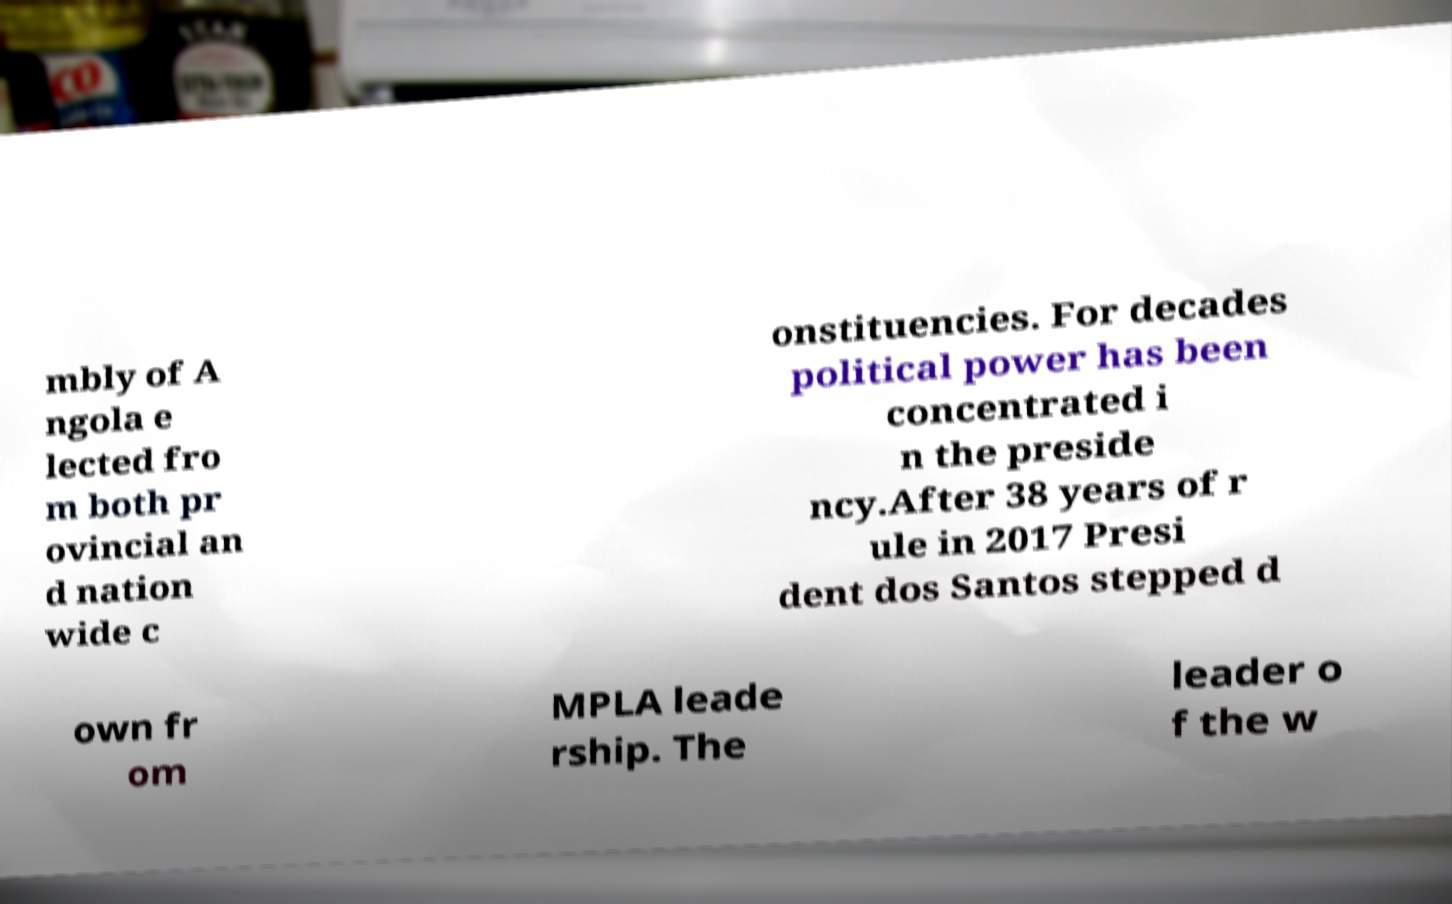Can you read and provide the text displayed in the image?This photo seems to have some interesting text. Can you extract and type it out for me? mbly of A ngola e lected fro m both pr ovincial an d nation wide c onstituencies. For decades political power has been concentrated i n the preside ncy.After 38 years of r ule in 2017 Presi dent dos Santos stepped d own fr om MPLA leade rship. The leader o f the w 